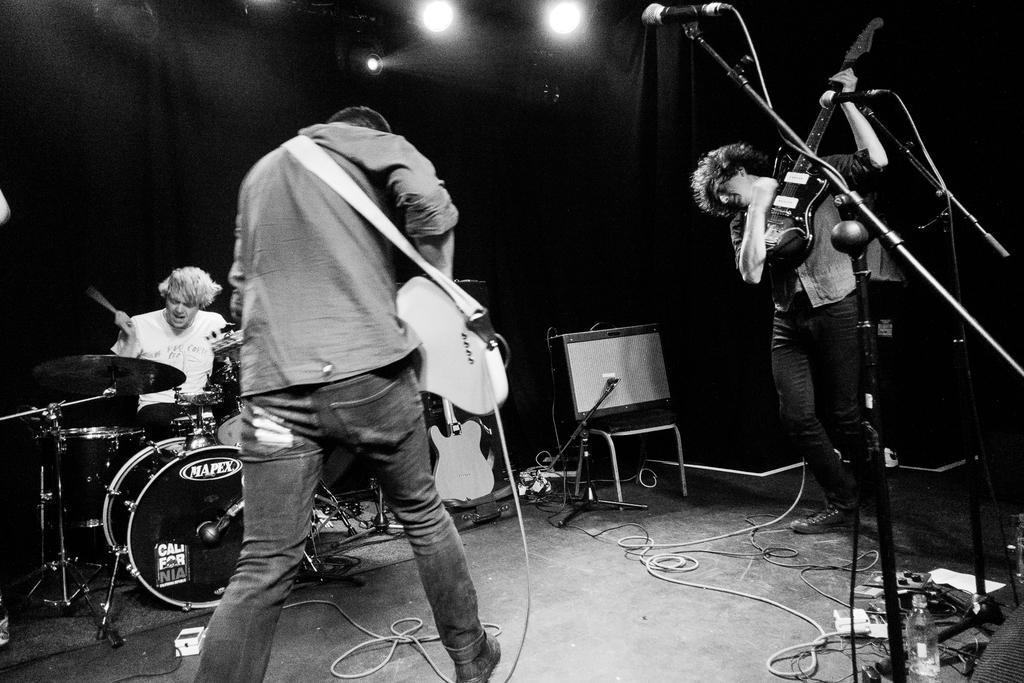Could you give a brief overview of what you see in this image? In this picture there is a man playing a guitar and the man sitting here and playing a drum set 